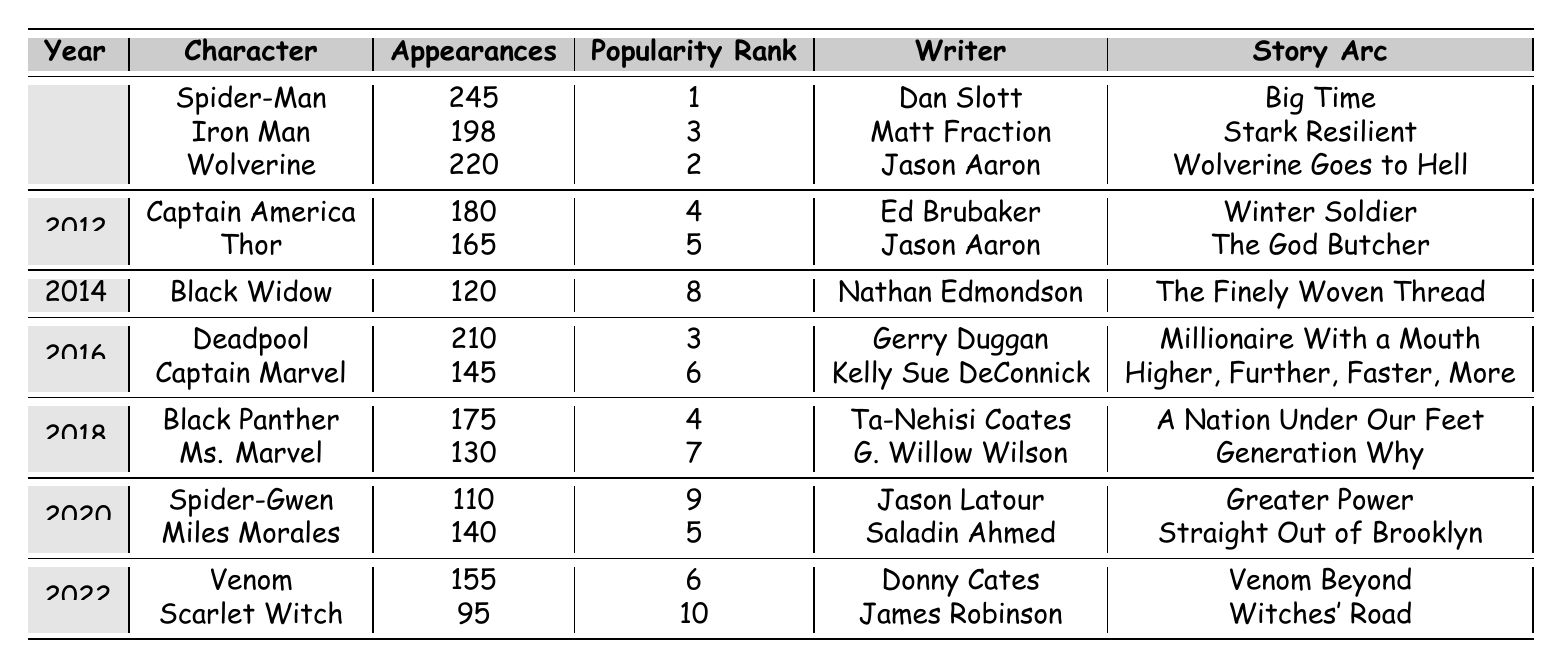What is the character with the highest number of appearances in 2010? In 2010, we check the appearances of each character listed. Spider-Man has 245 appearances, which is higher than Iron Man (198) and Wolverine (220). Thus, Spider-Man is the character with the highest appearances for that year.
Answer: Spider-Man What year did Black Widow first appear in the data? The table shows that Black Widow has data for the year 2014. Reviewing the years across all characters, 2014 is the first year she appears in this dataset.
Answer: 2014 Who is the writer for Captain Marvel? A look at the table shows that the writer listed for Captain Marvel is Kelly Sue DeConnick. This information can be found directly in the respective row for Captain Marvel.
Answer: Kelly Sue DeConnick What is the total number of appearances for characters from the year 2016? We sum the appearances for 2016: Deadpool has 210 and Captain Marvel has 145. Adding these gives 210 + 145 = 355. Therefore, the total appearances for that year is 355.
Answer: 355 Is it true that Thor has a higher popularity rank than Captain America? Checking the popularity ranks, Thor has a rank of 5 and Captain America has a rank of 4. Since 4 is better than 5 (lower is better), this statement is false.
Answer: No Which character has the lowest number of appearances in 2022? Reviewing the appearances of characters in 2022, Venom has 155 appearances while Scarlet Witch has 95. Scarlet Witch has the lowest number in that year.
Answer: Scarlet Witch What is the average popularity rank of characters who appeared in the year 2018? The characters from 2018 are Black Panther (rank 4) and Ms. Marvel (rank 7). To find the average rank, we calculate (4 + 7) / 2 = 5.5. Thus, the average popularity rank for 2018 is 5.5.
Answer: 5.5 Are there any characters who appeared more than 200 times in 2010? Looking specifically at 2010, Spider-Man appears 245 times, which is greater than 200, while Wolverine and Iron Man do not exceed that number. Thus, the answer is yes, Spider-Man is one.
Answer: Yes Which character had the most appearances between 2010 and 2022? Reviewing all the rows, Spider-Man has 245 appearances in 2010, which is the highest compared to appearances by other characters in subsequent years. Thus, Spider-Man had the most appearances in the entire range.
Answer: Spider-Man 